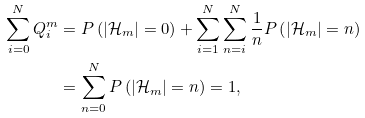Convert formula to latex. <formula><loc_0><loc_0><loc_500><loc_500>\sum _ { i = 0 } ^ { N } Q ^ { m } _ { i } & = P \left ( | \mathcal { H } _ { m } | = 0 \right ) + \sum _ { i = 1 } ^ { N } \sum _ { n = i } ^ { N } \frac { 1 } { n } P \left ( | \mathcal { H } _ { m } | = n \right ) \\ & = \sum _ { n = 0 } ^ { N } P \left ( | \mathcal { H } _ { m } | = n \right ) = 1 ,</formula> 